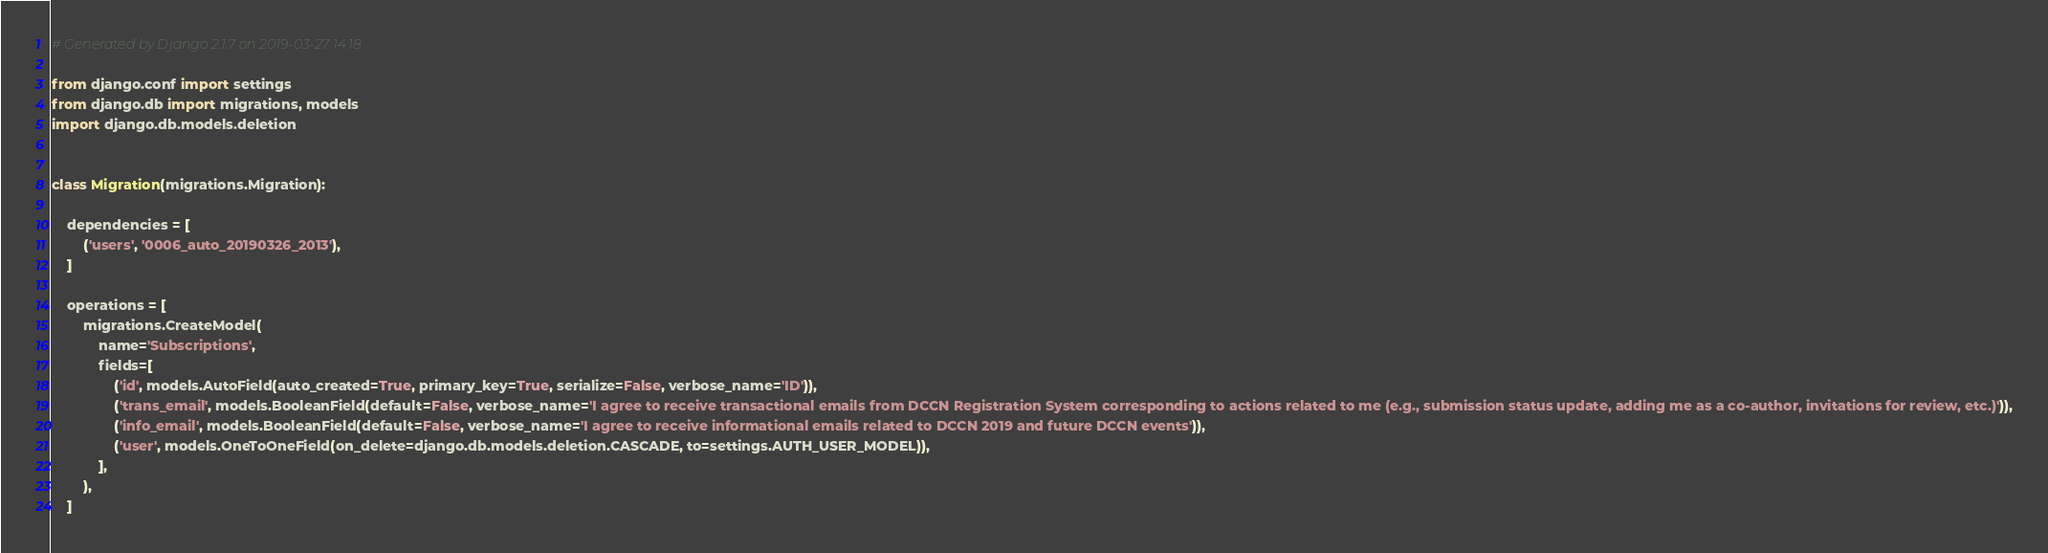<code> <loc_0><loc_0><loc_500><loc_500><_Python_># Generated by Django 2.1.7 on 2019-03-27 14:18

from django.conf import settings
from django.db import migrations, models
import django.db.models.deletion


class Migration(migrations.Migration):

    dependencies = [
        ('users', '0006_auto_20190326_2013'),
    ]

    operations = [
        migrations.CreateModel(
            name='Subscriptions',
            fields=[
                ('id', models.AutoField(auto_created=True, primary_key=True, serialize=False, verbose_name='ID')),
                ('trans_email', models.BooleanField(default=False, verbose_name='I agree to receive transactional emails from DCCN Registration System corresponding to actions related to me (e.g., submission status update, adding me as a co-author, invitations for review, etc.)')),
                ('info_email', models.BooleanField(default=False, verbose_name='I agree to receive informational emails related to DCCN 2019 and future DCCN events')),
                ('user', models.OneToOneField(on_delete=django.db.models.deletion.CASCADE, to=settings.AUTH_USER_MODEL)),
            ],
        ),
    ]
</code> 